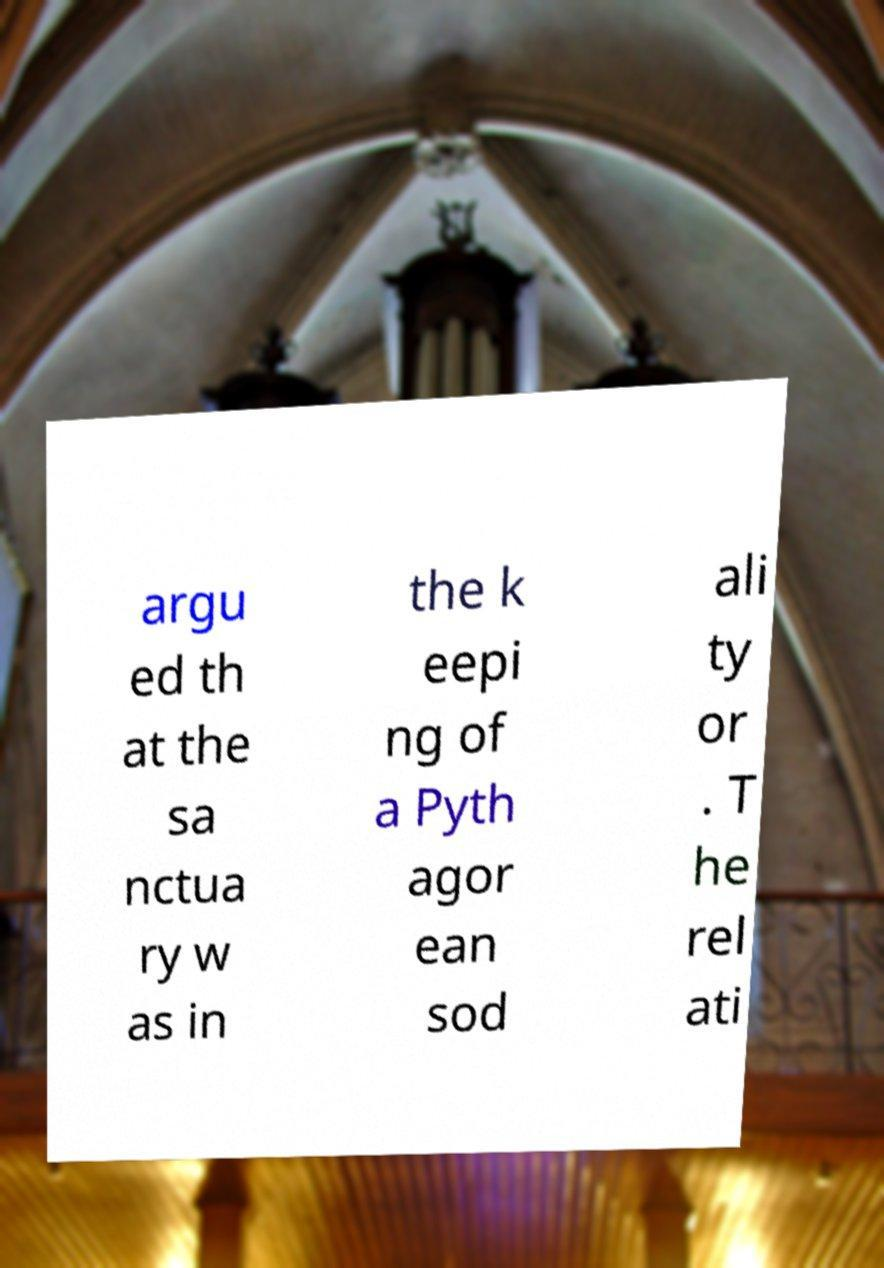What messages or text are displayed in this image? I need them in a readable, typed format. argu ed th at the sa nctua ry w as in the k eepi ng of a Pyth agor ean sod ali ty or . T he rel ati 